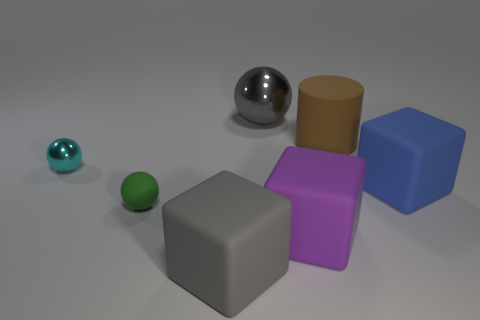What is the material of the thing that is the same color as the big sphere?
Your answer should be very brief. Rubber. There is a big cylinder; what number of blocks are on the left side of it?
Offer a very short reply. 2. Is the large gray block made of the same material as the brown object?
Offer a terse response. Yes. How many rubber blocks are in front of the green matte thing and on the right side of the gray matte thing?
Your response must be concise. 1. What number of other objects are there of the same color as the large sphere?
Give a very brief answer. 1. How many purple things are big rubber cylinders or matte objects?
Provide a succinct answer. 1. What size is the brown matte cylinder?
Offer a terse response. Large. How many metal objects are small cyan things or large cylinders?
Ensure brevity in your answer.  1. Are there fewer spheres than small purple metallic spheres?
Make the answer very short. No. How many other objects are there of the same material as the large purple object?
Offer a terse response. 4. 